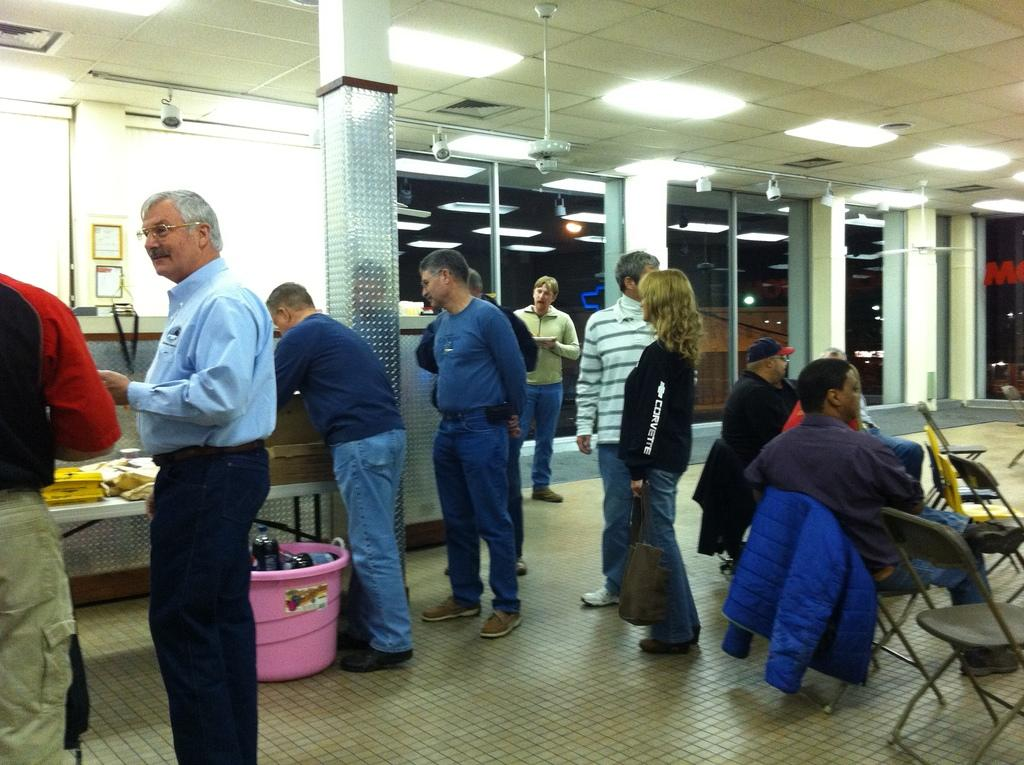What is the man on the left side of the image doing? The man is standing on the left side of the image. What is the man wearing? The man is wearing a blue shirt and trousers. What can be seen on the right side of the image? There are two persons sitting on chairs on the right side of the image. What is visible at the top of the image? There are lights visible at the top of the image. What type of furniture is the government using in the image? There is no reference to the government or any furniture in the image. How many nails can be seen in the image? There are no nails visible in the image. 